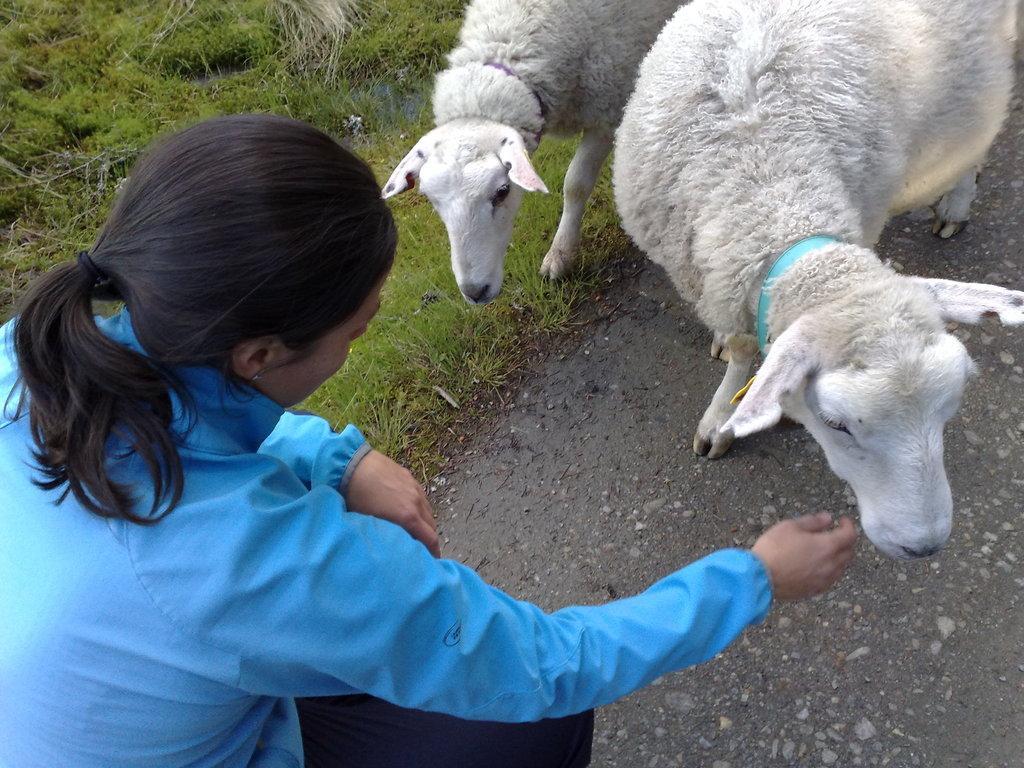Can you describe this image briefly? In this picture there is a woman sitting. There are two sheeps standing. At the bottom there is grass and there is a road. 